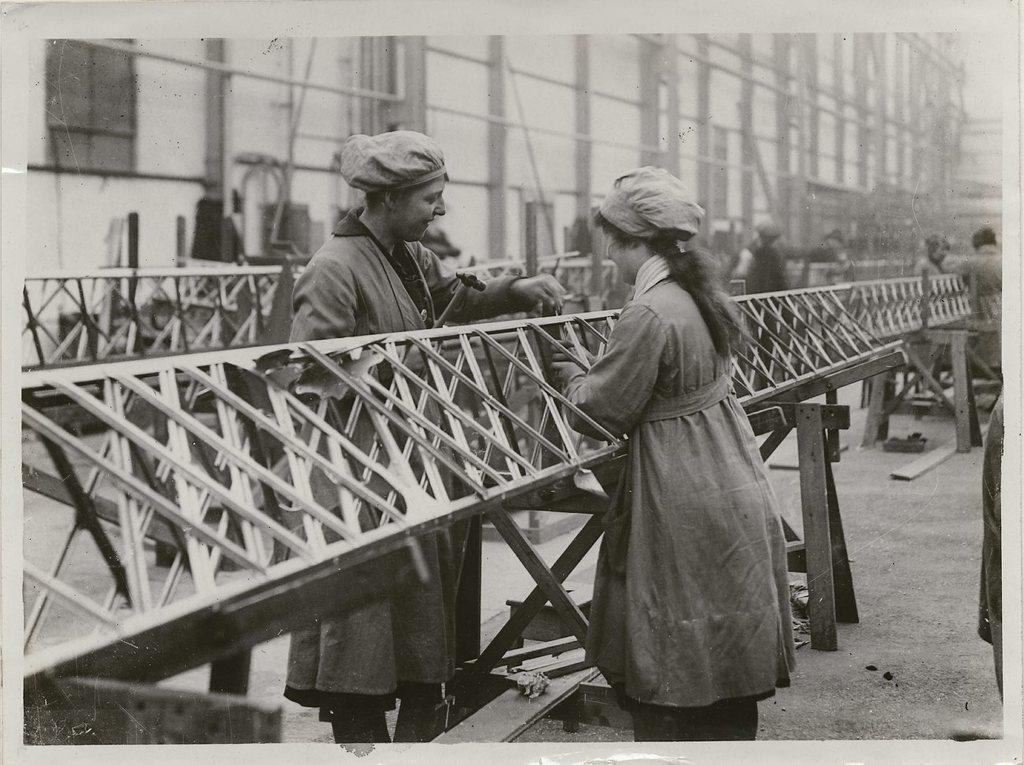In one or two sentences, can you explain what this image depicts? In this picture I can see few people standing near to the rods. In the background I can see a building and I can also see that, this is a black and white picture. 